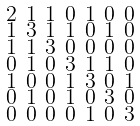Convert formula to latex. <formula><loc_0><loc_0><loc_500><loc_500>\begin{smallmatrix} 2 & 1 & 1 & 0 & 1 & 0 & 0 \\ 1 & 3 & 1 & 1 & 0 & 1 & 0 \\ 1 & 1 & 3 & 0 & 0 & 0 & 0 \\ 0 & 1 & 0 & 3 & 1 & 1 & 0 \\ 1 & 0 & 0 & 1 & 3 & 0 & 1 \\ 0 & 1 & 0 & 1 & 0 & 3 & 0 \\ 0 & 0 & 0 & 0 & 1 & 0 & 3 \end{smallmatrix}</formula> 